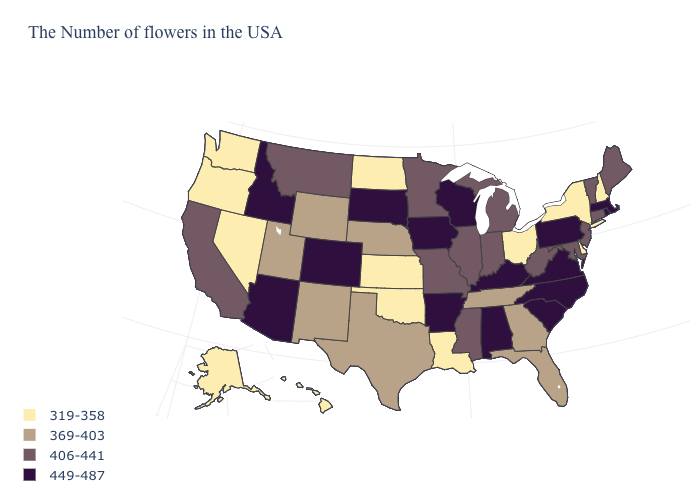What is the lowest value in states that border Wyoming?
Keep it brief. 369-403. Name the states that have a value in the range 319-358?
Quick response, please. New Hampshire, New York, Delaware, Ohio, Louisiana, Kansas, Oklahoma, North Dakota, Nevada, Washington, Oregon, Alaska, Hawaii. Name the states that have a value in the range 449-487?
Keep it brief. Massachusetts, Rhode Island, Pennsylvania, Virginia, North Carolina, South Carolina, Kentucky, Alabama, Wisconsin, Arkansas, Iowa, South Dakota, Colorado, Arizona, Idaho. What is the value of North Carolina?
Quick response, please. 449-487. Does New Mexico have the same value as Oregon?
Answer briefly. No. Name the states that have a value in the range 319-358?
Quick response, please. New Hampshire, New York, Delaware, Ohio, Louisiana, Kansas, Oklahoma, North Dakota, Nevada, Washington, Oregon, Alaska, Hawaii. What is the value of Mississippi?
Keep it brief. 406-441. Name the states that have a value in the range 406-441?
Give a very brief answer. Maine, Vermont, Connecticut, New Jersey, Maryland, West Virginia, Michigan, Indiana, Illinois, Mississippi, Missouri, Minnesota, Montana, California. Does the first symbol in the legend represent the smallest category?
Give a very brief answer. Yes. Does Indiana have the highest value in the MidWest?
Answer briefly. No. Does Maine have a lower value than Texas?
Keep it brief. No. What is the lowest value in states that border West Virginia?
Give a very brief answer. 319-358. Does the first symbol in the legend represent the smallest category?
Keep it brief. Yes. Among the states that border Michigan , does Wisconsin have the highest value?
Short answer required. Yes. 